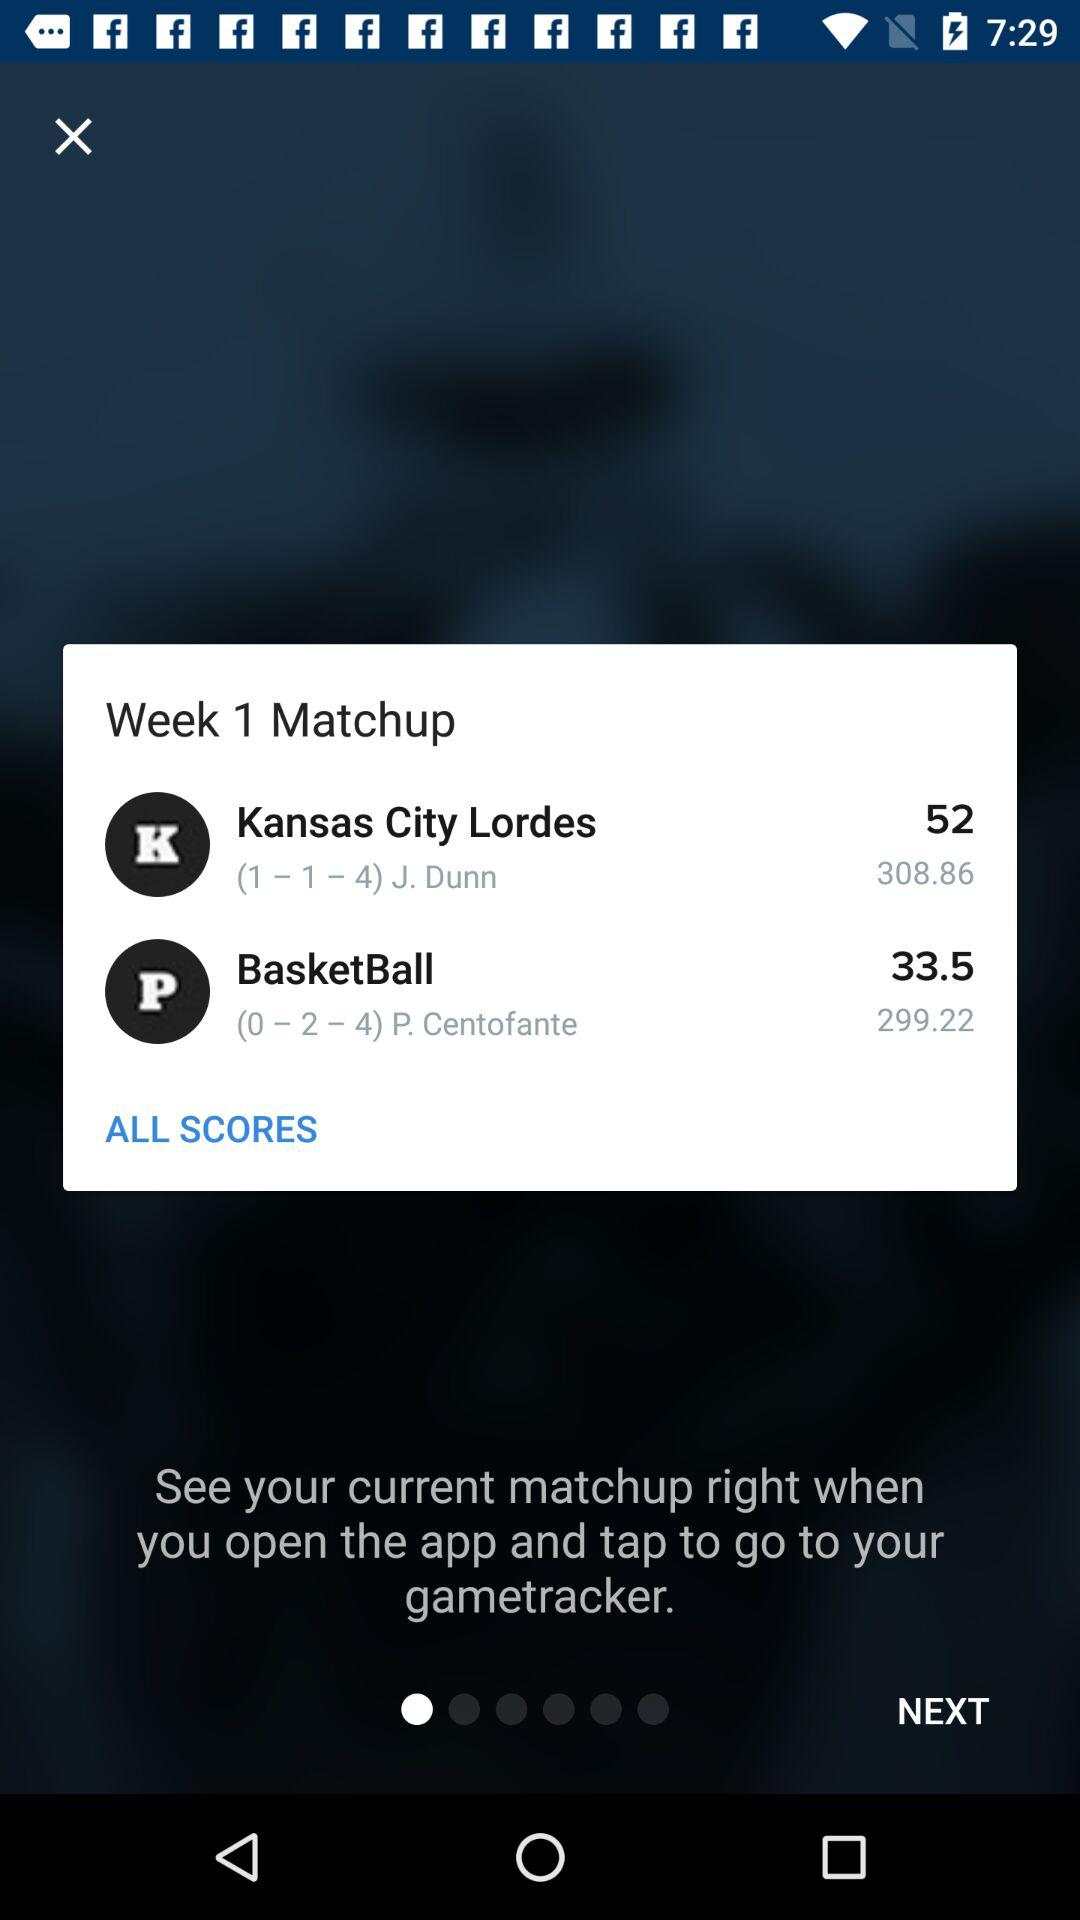How many more points did Kansas City Lordes score than Basketball?
Answer the question using a single word or phrase. 18.5 